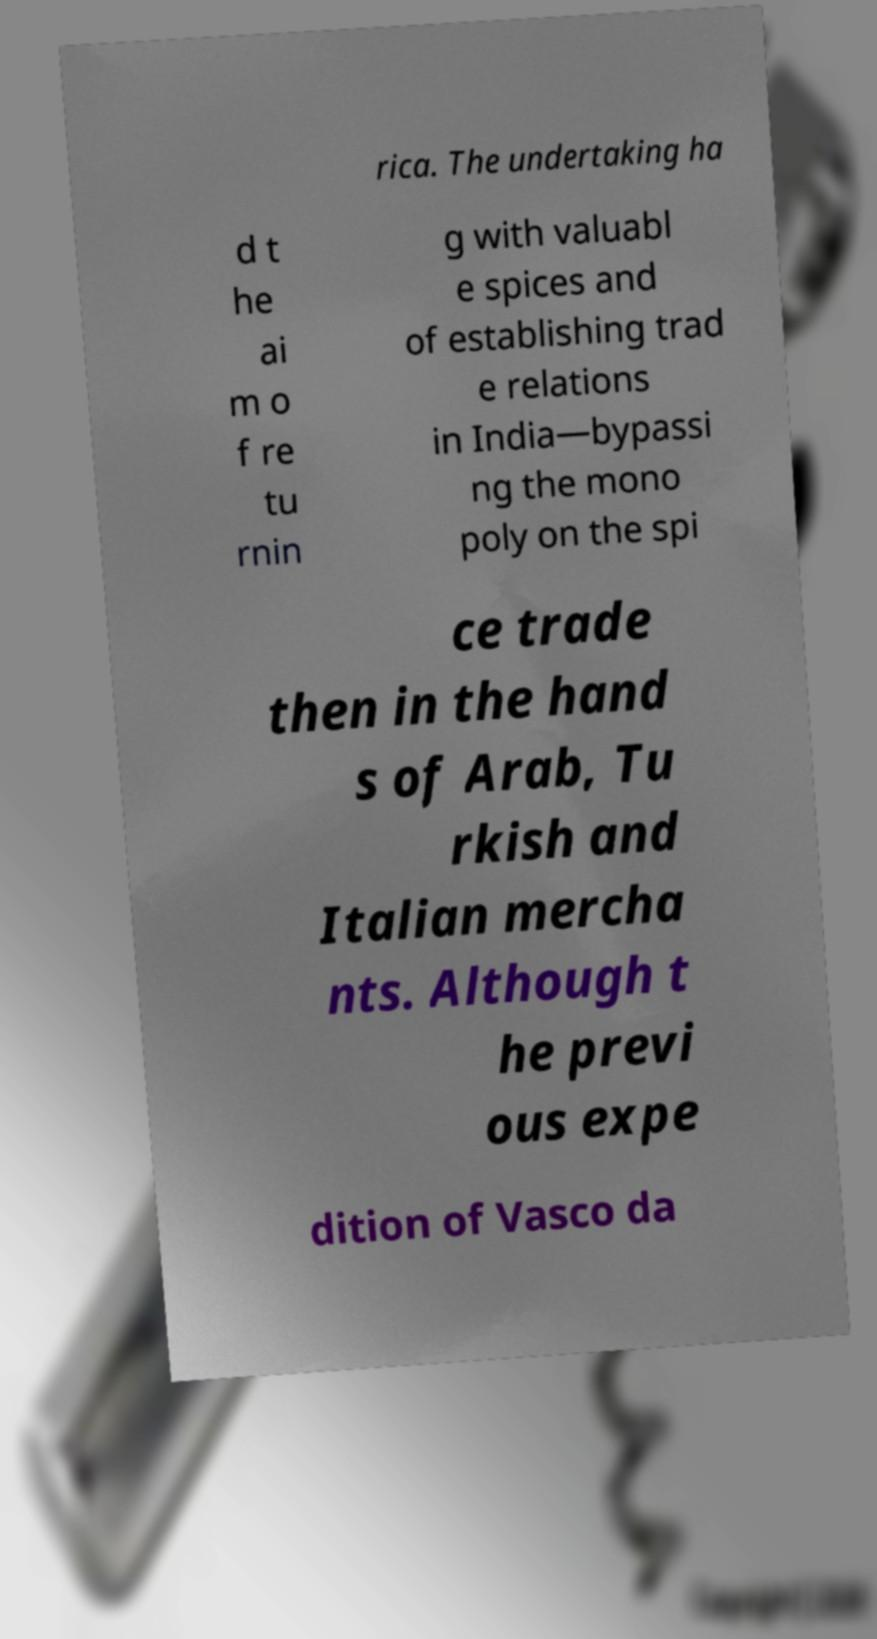Please identify and transcribe the text found in this image. rica. The undertaking ha d t he ai m o f re tu rnin g with valuabl e spices and of establishing trad e relations in India—bypassi ng the mono poly on the spi ce trade then in the hand s of Arab, Tu rkish and Italian mercha nts. Although t he previ ous expe dition of Vasco da 